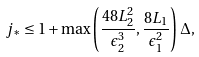Convert formula to latex. <formula><loc_0><loc_0><loc_500><loc_500>j _ { * } \leq 1 + \max \left ( \frac { 4 8 L _ { 2 } ^ { 2 } } { \epsilon _ { 2 } ^ { 3 } } , \frac { 8 L _ { 1 } } { \epsilon _ { 1 } ^ { 2 } } \right ) \Delta ,</formula> 